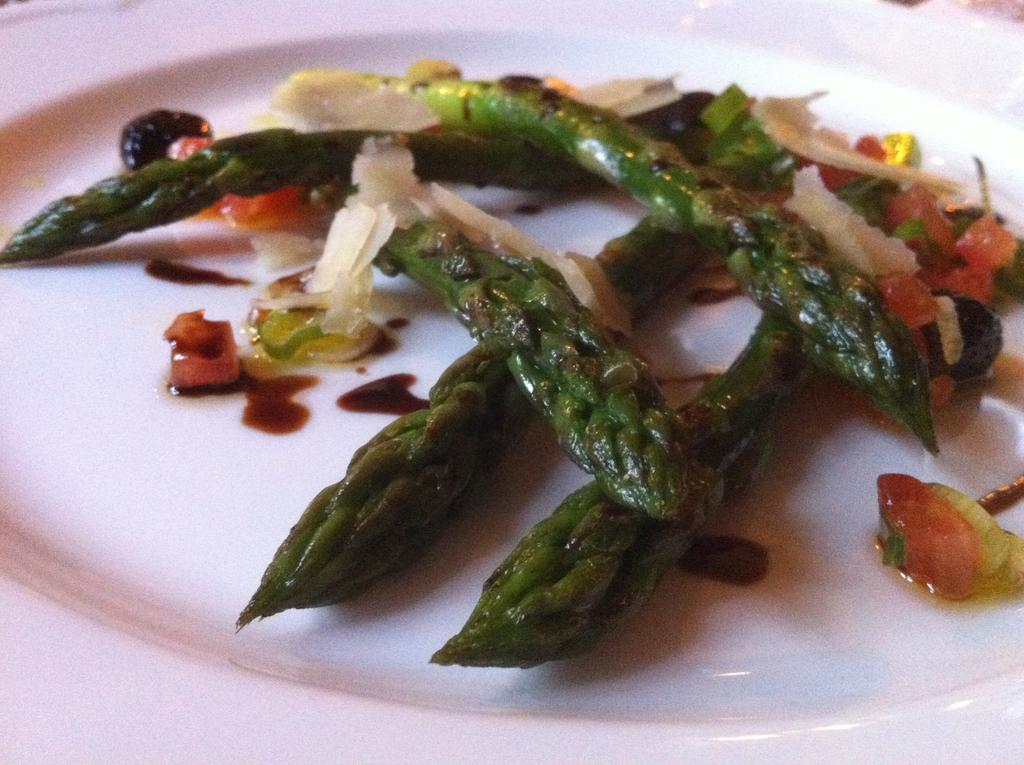What can be seen on the plate in the image? There is a dish on the plate in the image. Can you describe the dish on the plate? Unfortunately, the facts provided do not give any details about the dish on the plate. Is there a quill used for writing on the plate in the image? No, there is no quill present on the plate in the image. 